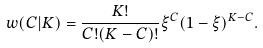<formula> <loc_0><loc_0><loc_500><loc_500>w ( C | K ) = \frac { K ! } { C ! ( K - C ) ! } \xi ^ { C } ( 1 - \xi ) ^ { K - C } .</formula> 